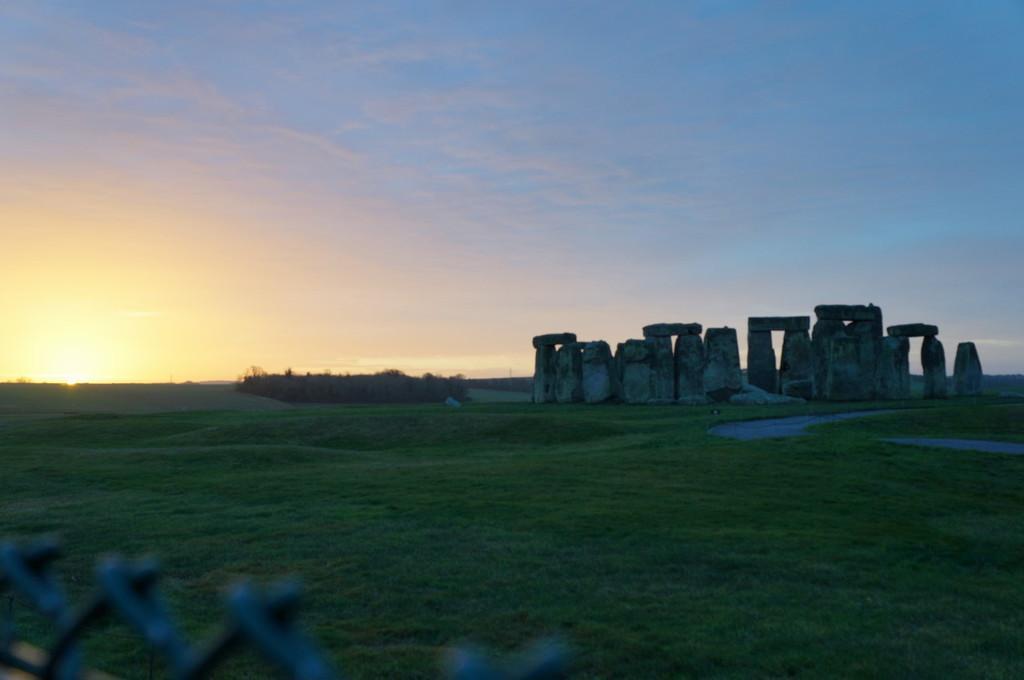How would you summarize this image in a sentence or two? This picture is taken from outside of the city. In this image, in the left corner, we can see a metal fence. On the right side, we can see some rocks. In the background, we can see some trees, plants, sun. At the top, we can see a sky, at the bottom, we can see a grass and a water. 